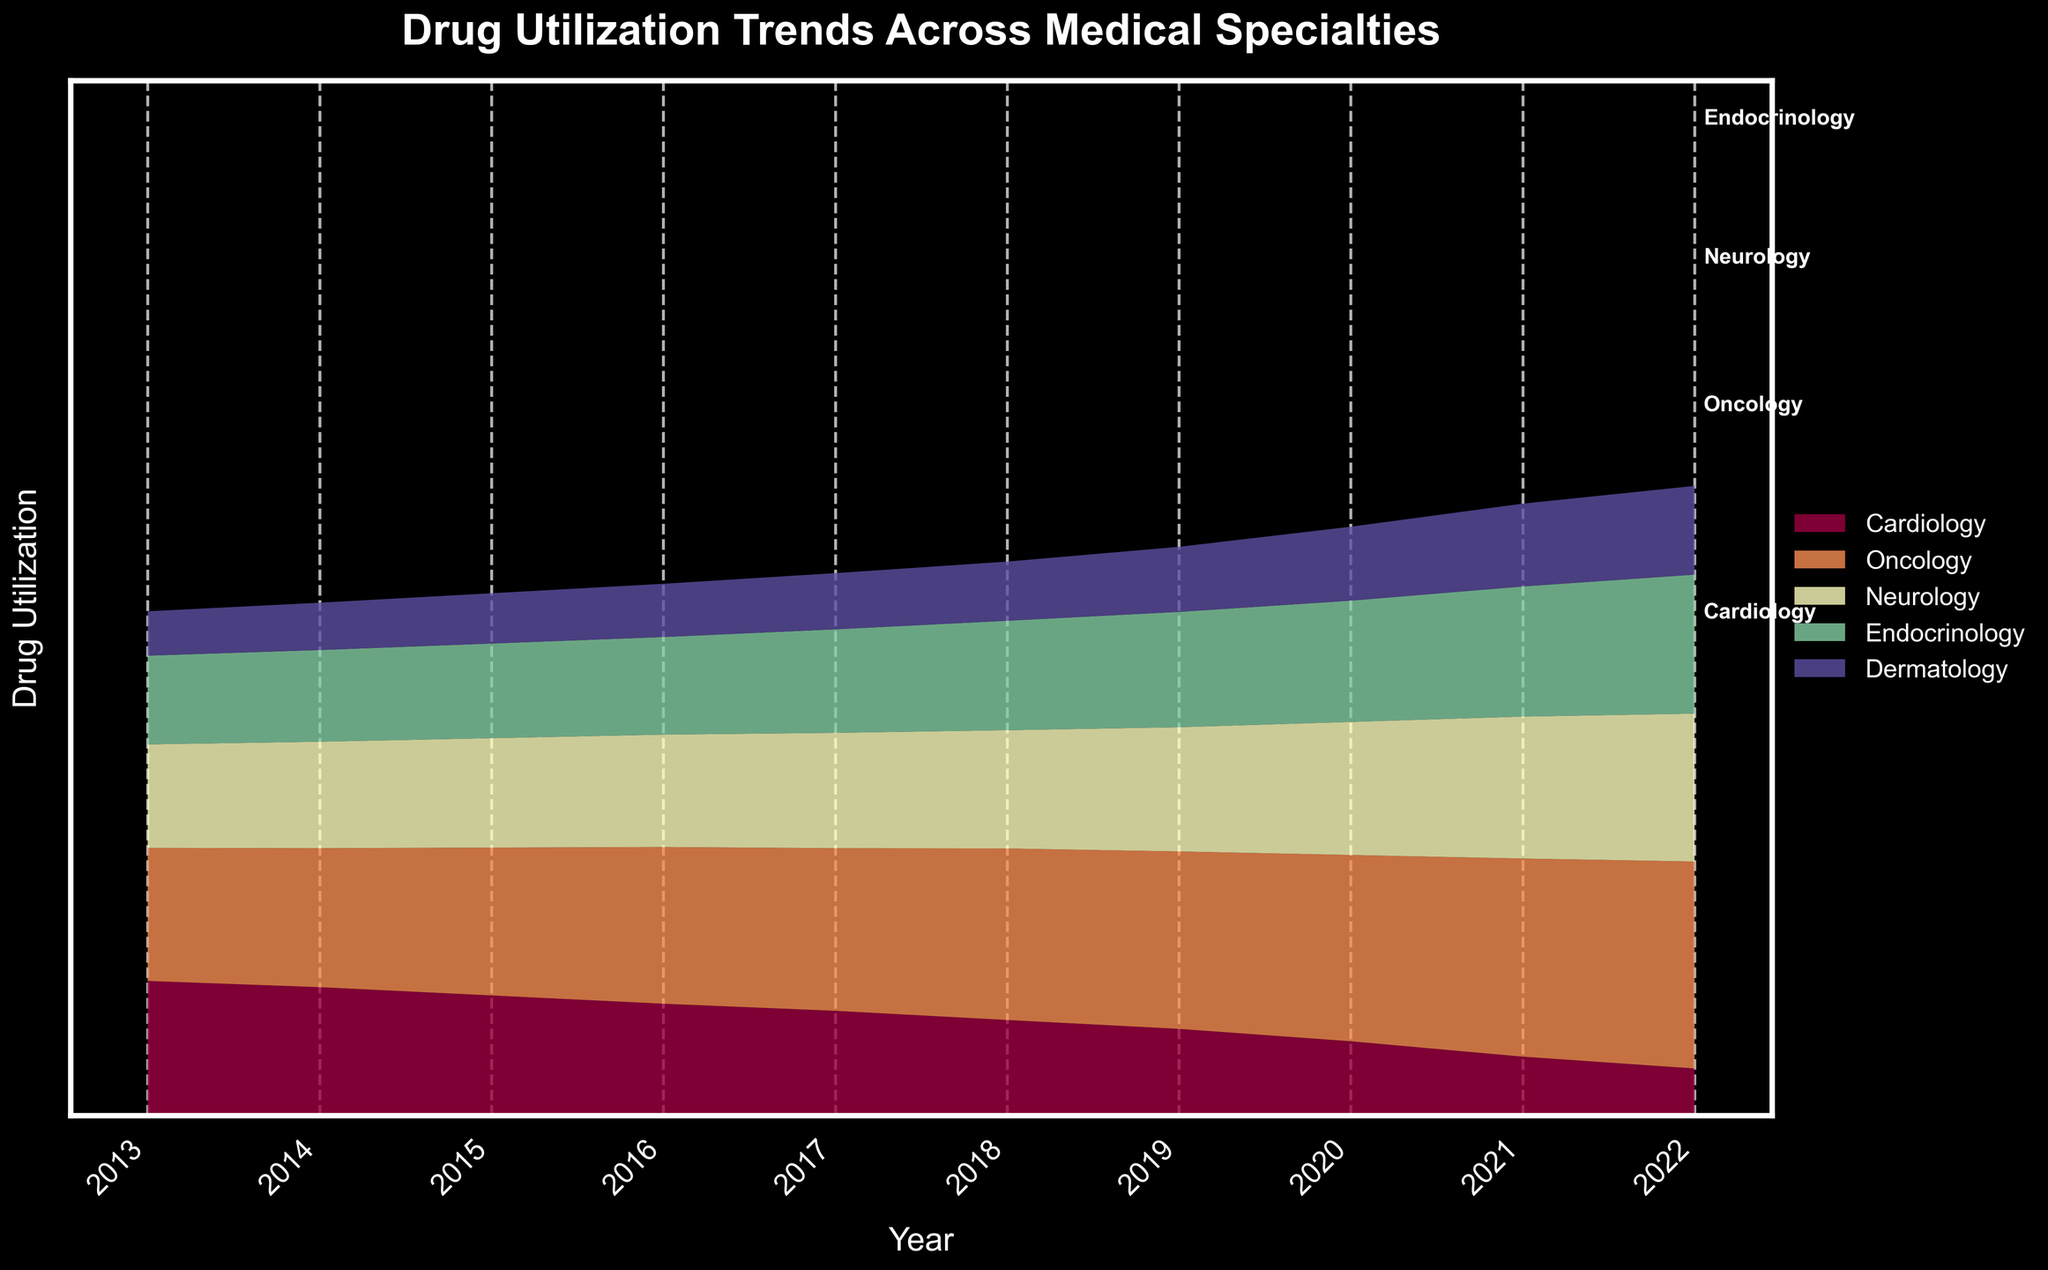What is the title of the graph? The title of the graph is written at the top of the figure and states the main focus of the graph.
Answer: Drug Utilization Trends Across Medical Specialties What does the y-axis represent? The y-axis represents the quantity of drug utilization, which is labeled as "Drug Utilization".
Answer: Drug Utilization What trend can be observed in the Cardiology specialty over the past decade? By examining the area corresponding to Cardiology, you can see that it shows a continuous increase from 2013 to 2022.
Answer: Increasing trend Which specialty had the highest drug utilization in 2022? By looking at the top layer of the graph in 2022, we can see that Cardiology had the largest area, indicating the highest drug utilization.
Answer: Cardiology How did the drug utilization in Oncology change from 2013 to 2019? Observing the Oncology area from 2013 to 2019, we can see it increasing steadily year by year.
Answer: Steady increase In which year did Dermatology see the largest increase in drug utilization? To determine this, observe the width of each incremental segment representing Dermatology year-to-year; the segment from 2019 to 2020 appears the largest.
Answer: 2020 Which two specialties showed the biggest difference in drug utilization in 2022? In 2022, the areas corresponding to Cardiology and Dermatology are compared and show the largest difference, with Cardiology being much larger.
Answer: Cardiology and Dermatology What can you infer about the trend in Neurology drug utilization between 2013 and 2022? Observing Neurology's area in the graph, it increases steadily from 2013 to 2022.
Answer: Increasing trend Compare the trends in Endocrinology and Dermatology over the entire period. Both Endocrinology and Dermatology show an increasing trend, but Endocrinology has a sharper rise as evidenced by the larger areas in the later years compared to Dermatology.
Answer: Both increasing, Endocrinology sharper Which specialty saw the smallest increase in drug utilization from 2013 to 2022? Comparing the areas for each specialty from 2013 to 2022, Dermatology has the smallest incremental change.
Answer: Dermatology 